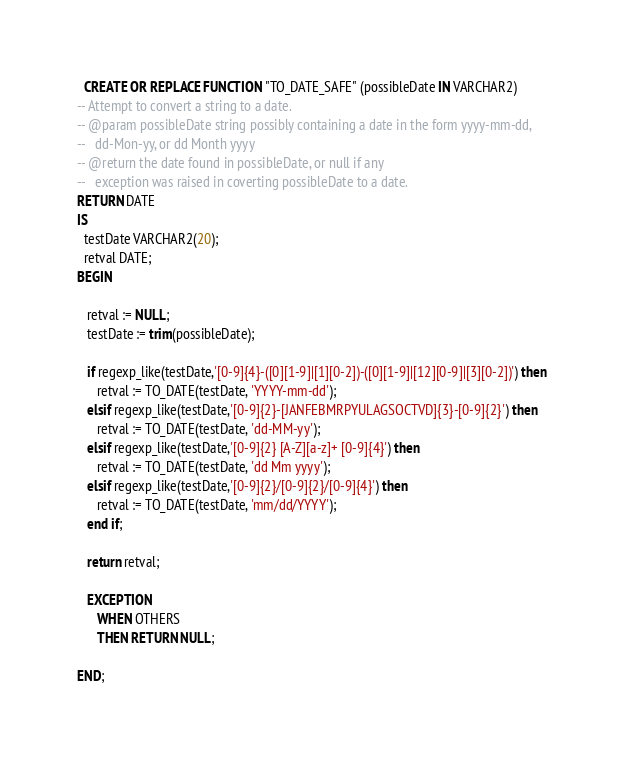<code> <loc_0><loc_0><loc_500><loc_500><_SQL_>  CREATE OR REPLACE FUNCTION "TO_DATE_SAFE" (possibleDate IN VARCHAR2)
-- Attempt to convert a string to a date.
-- @param possibleDate string possibly containing a date in the form yyyy-mm-dd, 
--   dd-Mon-yy, or dd Month yyyy
-- @return the date found in possibleDate, or null if any
--   exception was raised in coverting possibleDate to a date.
RETURN DATE
IS
  testDate VARCHAR2(20);
  retval DATE;
BEGIN

   retval := NULL;
   testDate := trim(possibleDate);

   if regexp_like(testDate,'[0-9]{4}-([0][1-9]|[1][0-2])-([0][1-9]|[12][0-9]|[3][0-2])') then
      retval := TO_DATE(testDate, 'YYYY-mm-dd');
   elsif regexp_like(testDate,'[0-9]{2}-[JANFEBMRPYULAGSOCTVD]{3}-[0-9]{2}') then
      retval := TO_DATE(testDate, 'dd-MM-yy');
   elsif regexp_like(testDate,'[0-9]{2} [A-Z][a-z]+ [0-9]{4}') then
      retval := TO_DATE(testDate, 'dd Mm yyyy');
   elsif regexp_like(testDate,'[0-9]{2}/[0-9]{2}/[0-9]{4}') then
      retval := TO_DATE(testDate, 'mm/dd/YYYY');
   end if;   

   return retval;

   EXCEPTION
      WHEN OTHERS
      THEN RETURN NULL;

END;</code> 